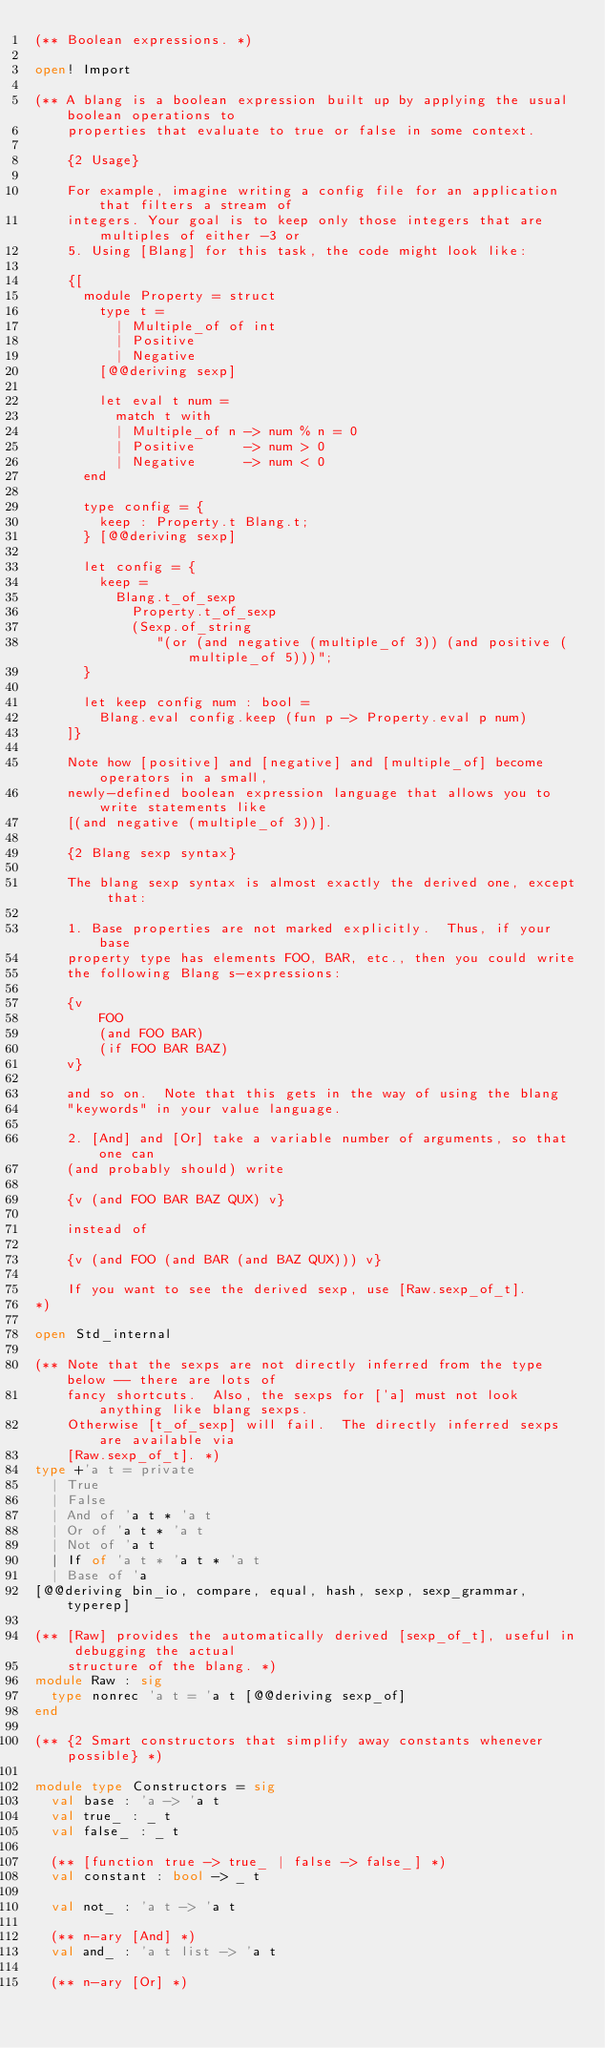Convert code to text. <code><loc_0><loc_0><loc_500><loc_500><_OCaml_>(** Boolean expressions. *)

open! Import

(** A blang is a boolean expression built up by applying the usual boolean operations to
    properties that evaluate to true or false in some context.

    {2 Usage}

    For example, imagine writing a config file for an application that filters a stream of
    integers. Your goal is to keep only those integers that are multiples of either -3 or
    5. Using [Blang] for this task, the code might look like:

    {[
      module Property = struct
        type t =
          | Multiple_of of int
          | Positive
          | Negative
        [@@deriving sexp]

        let eval t num =
          match t with
          | Multiple_of n -> num % n = 0
          | Positive      -> num > 0
          | Negative      -> num < 0
      end

      type config = {
        keep : Property.t Blang.t;
      } [@@deriving sexp]

      let config = {
        keep =
          Blang.t_of_sexp
            Property.t_of_sexp
            (Sexp.of_string
               "(or (and negative (multiple_of 3)) (and positive (multiple_of 5)))";
      }

      let keep config num : bool =
        Blang.eval config.keep (fun p -> Property.eval p num)
    ]}

    Note how [positive] and [negative] and [multiple_of] become operators in a small,
    newly-defined boolean expression language that allows you to write statements like
    [(and negative (multiple_of 3))].

    {2 Blang sexp syntax}

    The blang sexp syntax is almost exactly the derived one, except that:

    1. Base properties are not marked explicitly.  Thus, if your base
    property type has elements FOO, BAR, etc., then you could write
    the following Blang s-expressions:

    {v
        FOO
        (and FOO BAR)
        (if FOO BAR BAZ)
    v}

    and so on.  Note that this gets in the way of using the blang
    "keywords" in your value language.

    2. [And] and [Or] take a variable number of arguments, so that one can
    (and probably should) write

    {v (and FOO BAR BAZ QUX) v}

    instead of

    {v (and FOO (and BAR (and BAZ QUX))) v}

    If you want to see the derived sexp, use [Raw.sexp_of_t].
*)

open Std_internal

(** Note that the sexps are not directly inferred from the type below -- there are lots of
    fancy shortcuts.  Also, the sexps for ['a] must not look anything like blang sexps.
    Otherwise [t_of_sexp] will fail.  The directly inferred sexps are available via
    [Raw.sexp_of_t]. *)
type +'a t = private
  | True
  | False
  | And of 'a t * 'a t
  | Or of 'a t * 'a t
  | Not of 'a t
  | If of 'a t * 'a t * 'a t
  | Base of 'a
[@@deriving bin_io, compare, equal, hash, sexp, sexp_grammar, typerep]

(** [Raw] provides the automatically derived [sexp_of_t], useful in debugging the actual
    structure of the blang. *)
module Raw : sig
  type nonrec 'a t = 'a t [@@deriving sexp_of]
end

(** {2 Smart constructors that simplify away constants whenever possible} *)

module type Constructors = sig
  val base : 'a -> 'a t
  val true_ : _ t
  val false_ : _ t

  (** [function true -> true_ | false -> false_] *)
  val constant : bool -> _ t

  val not_ : 'a t -> 'a t

  (** n-ary [And] *)
  val and_ : 'a t list -> 'a t

  (** n-ary [Or] *)</code> 